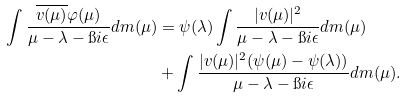<formula> <loc_0><loc_0><loc_500><loc_500>\int \frac { \overline { v ( \mu ) } \varphi ( \mu ) } { \mu - \lambda - \i i \epsilon } d m ( \mu ) & = \psi ( \lambda ) \int \frac { | v ( \mu ) | ^ { 2 } } { \mu - \lambda - \i i \epsilon } d m ( \mu ) \\ & + \int \frac { | v ( \mu ) | ^ { 2 } ( \psi ( \mu ) - \psi ( \lambda ) ) } { \mu - \lambda - \i i \epsilon } d m ( \mu ) .</formula> 